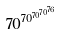Convert formula to latex. <formula><loc_0><loc_0><loc_500><loc_500>7 0 ^ { 7 0 ^ { 7 0 ^ { 7 0 ^ { 7 6 } } } }</formula> 